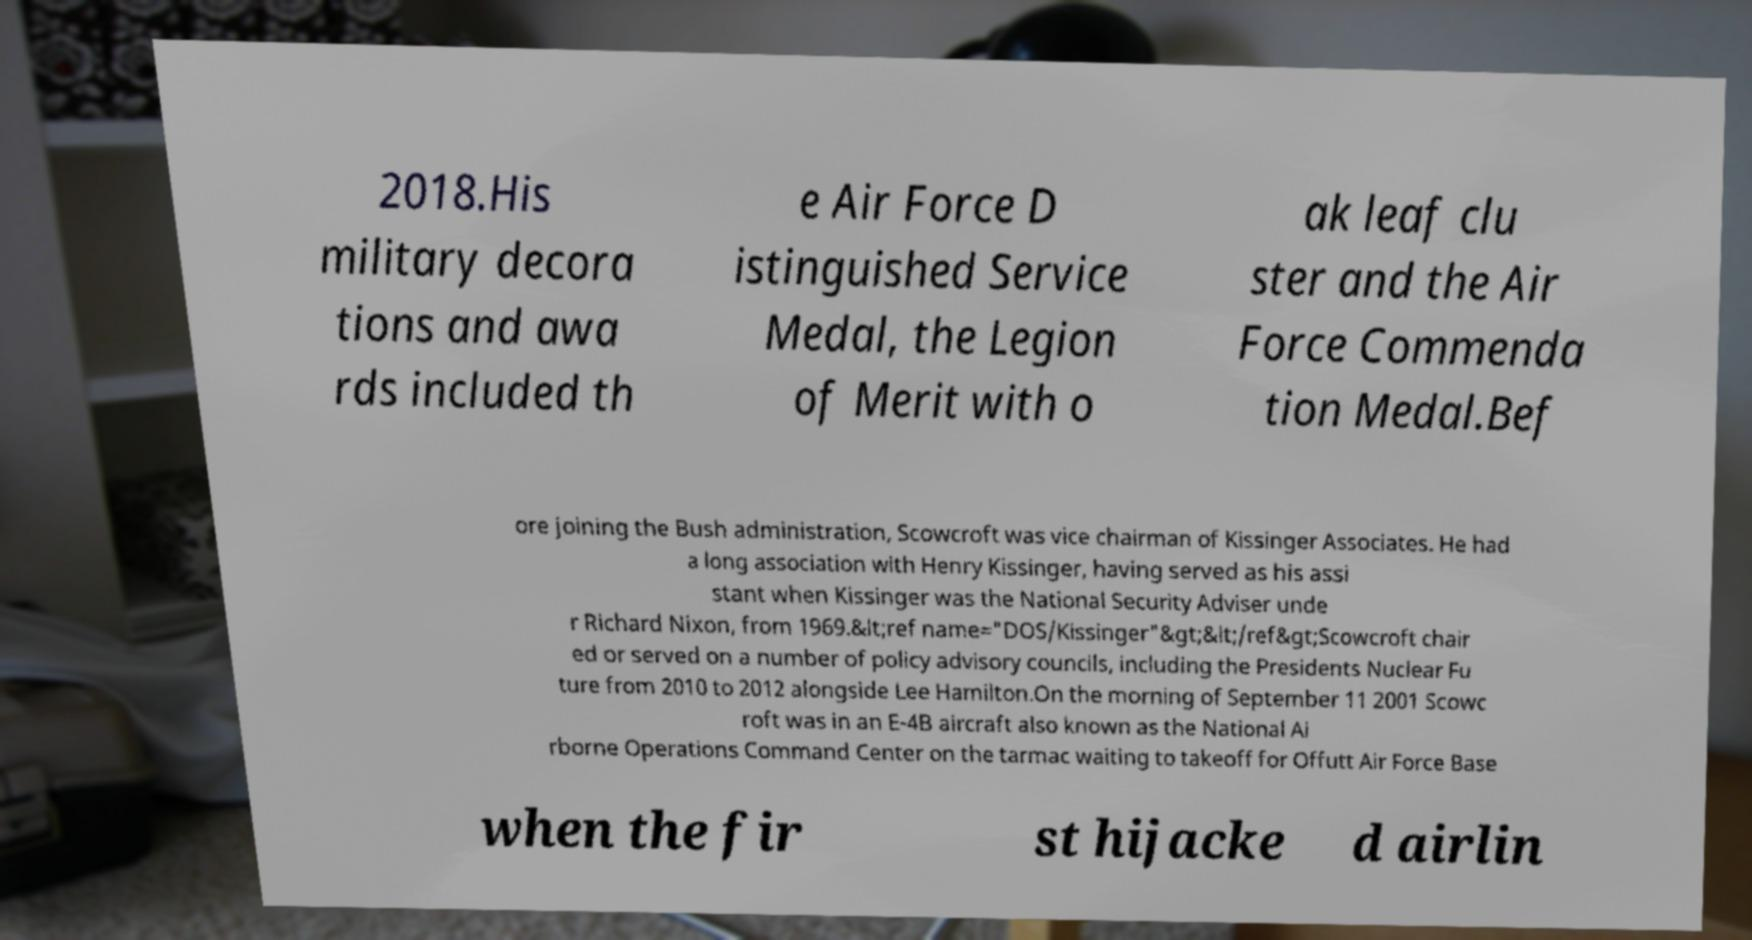I need the written content from this picture converted into text. Can you do that? 2018.His military decora tions and awa rds included th e Air Force D istinguished Service Medal, the Legion of Merit with o ak leaf clu ster and the Air Force Commenda tion Medal.Bef ore joining the Bush administration, Scowcroft was vice chairman of Kissinger Associates. He had a long association with Henry Kissinger, having served as his assi stant when Kissinger was the National Security Adviser unde r Richard Nixon, from 1969.&lt;ref name="DOS/Kissinger"&gt;&lt;/ref&gt;Scowcroft chair ed or served on a number of policy advisory councils, including the Presidents Nuclear Fu ture from 2010 to 2012 alongside Lee Hamilton.On the morning of September 11 2001 Scowc roft was in an E-4B aircraft also known as the National Ai rborne Operations Command Center on the tarmac waiting to takeoff for Offutt Air Force Base when the fir st hijacke d airlin 